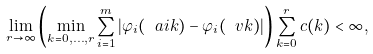<formula> <loc_0><loc_0><loc_500><loc_500>\lim _ { r \to \infty } \left ( \min _ { k = 0 , \dots , r } \sum _ { i = 1 } ^ { m } | \varphi _ { i } ( \ a i k ) - \varphi _ { i } ( \ v k ) | \right ) \sum _ { k = 0 } ^ { r } c ( k ) < \infty ,</formula> 